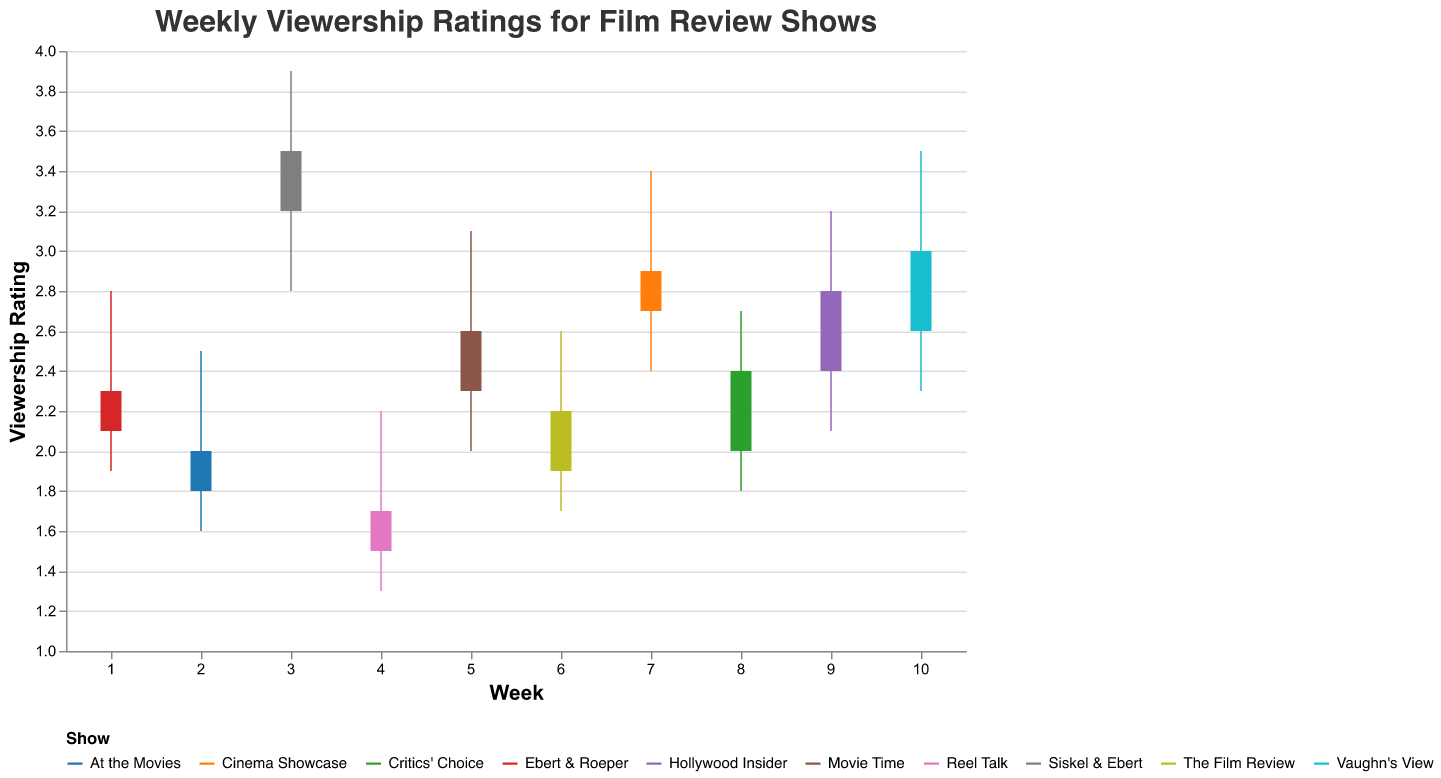What is the title of the chart? The title of the chart is displayed at the top and reads "Weekly Viewership Ratings for Film Review Shows".
Answer: Weekly Viewership Ratings for Film Review Shows Which show had the highest peak rating and what was it? "Siskel & Ebert" had the highest peak rating. By observing the highest value on the Y-axis, "Siskel & Ebert" peaked at a viewership rating of 3.9.
Answer: Siskel & Ebert, 3.9 Which show had the lowest closing rating and what was it? "Reel Talk" had the lowest closing rating. By looking at the closing values on the bars, we can determine "Reel Talk" closed at a rating of 1.7.
Answer: Reel Talk, 1.7 What is the range of viewership ratings for "Vaughn's View"? To find the range, subtract the lowest rating from the highest rating for "Vaughn's View". The lowest rating is 2.3 and the highest is 3.5, so the range is 3.5 - 2.3.
Answer: 1.2 Which show had a higher opening rating, “Ebert & Roeper” or “Cinema Showcase”? By comparing the opening ratings, "Ebert & Roeper" opened at 2.1 and "Cinema Showcase" opened at 2.7. Therefore, "Cinema Showcase" had a higher opening rating.
Answer: Cinema Showcase How many shows had their highest rating above 3? By observing the chart, the shows with highest ratings above 3 are "Siskel & Ebert", "Movie Time", "Cinema Showcase", "Hollywood Insider", and "Vaughn's View". Counting these shows, there are five.
Answer: 5 For how many shows did the closing rating increase compared to the opening rating? By checking the opening and closing values: Ebert & Roeper (2.1 to 2.3), At the Movies (1.8 to 2.0), Siskel & Ebert (3.2 to 3.5), Movie Time (2.3 to 2.6), Critics' Choice (2.0 to 2.4), Hollywood Insider (2.4 to 2.8), and Vaughn’s View (2.6 to 3.0) show an increase. In total, 7 shows had increased closing ratings.
Answer: 7 Which show has the least fluctuation in viewership ratings? To identify the least fluctuation, look for the smallest difference between the highest and lowest values. "Reel Talk" with highest at 2.2 and lowest at 1.3 has a fluctuation of 0.9, which is the smallest.
Answer: Reel Talk 